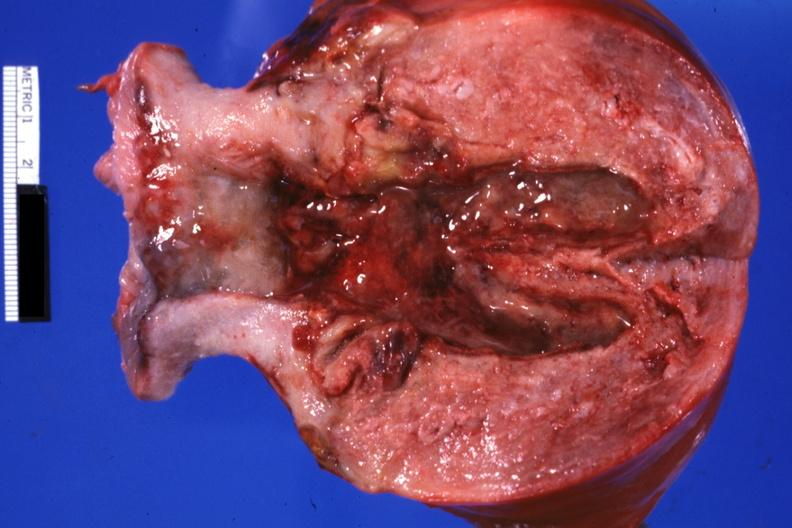where does this part belong to?
Answer the question using a single word or phrase. Female reproductive system 